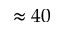<formula> <loc_0><loc_0><loc_500><loc_500>\approx 4 0</formula> 